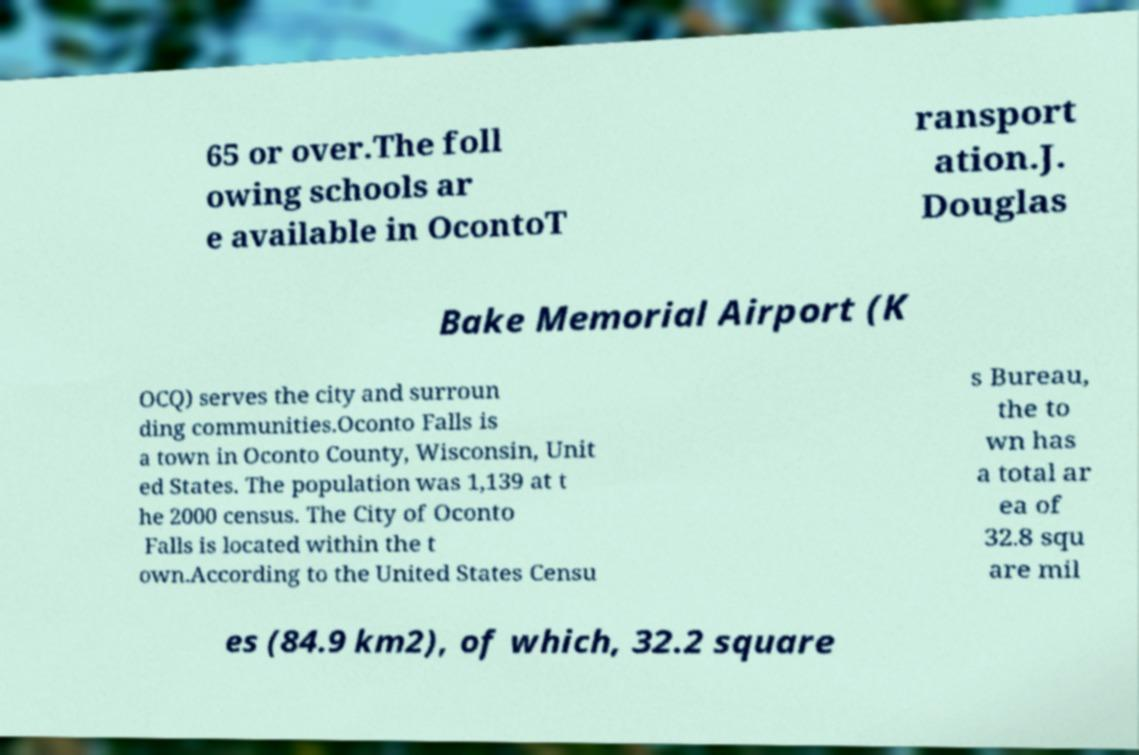There's text embedded in this image that I need extracted. Can you transcribe it verbatim? 65 or over.The foll owing schools ar e available in OcontoT ransport ation.J. Douglas Bake Memorial Airport (K OCQ) serves the city and surroun ding communities.Oconto Falls is a town in Oconto County, Wisconsin, Unit ed States. The population was 1,139 at t he 2000 census. The City of Oconto Falls is located within the t own.According to the United States Censu s Bureau, the to wn has a total ar ea of 32.8 squ are mil es (84.9 km2), of which, 32.2 square 